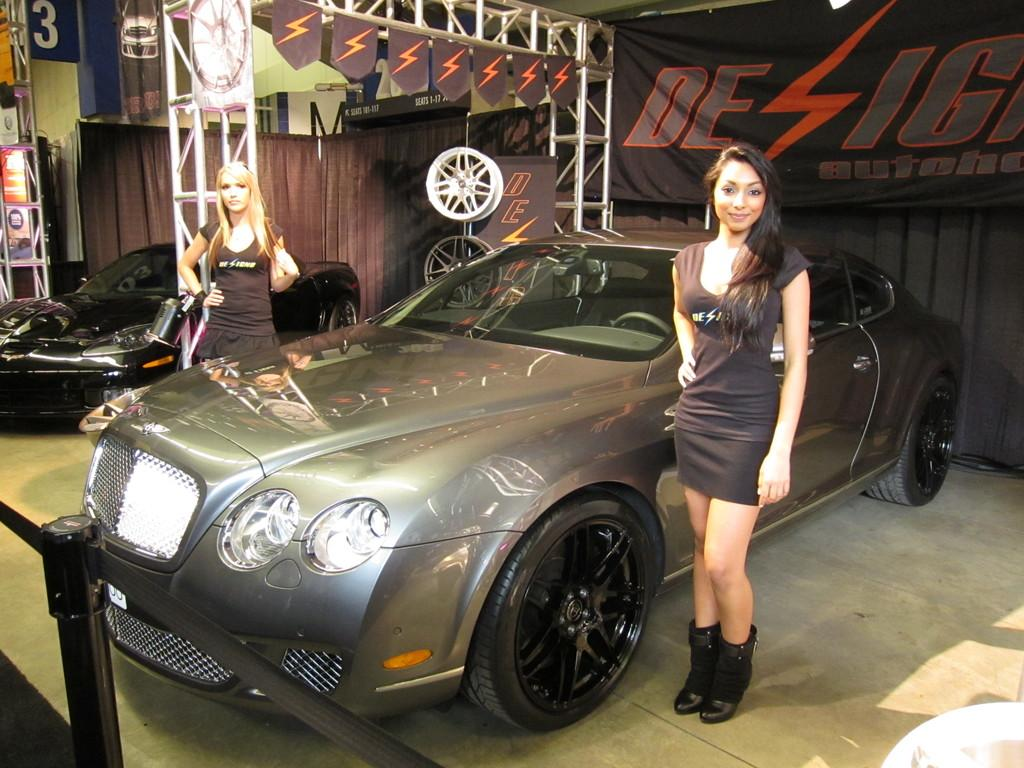What types of objects are present in the image? There are vehicles, a barrier, and a metal arch in the image. Can you describe the people in the image? There are two persons standing in the image. What might the barrier be used for? The barrier could be used to control traffic or separate areas. What types of food can be seen growing on the metal arch in the image? There are no plants or food visible on the metal arch in the image. How does the hearing of the persons in the image compare to each other? There is no information about the hearing of the persons in the image, so it cannot be compared. 